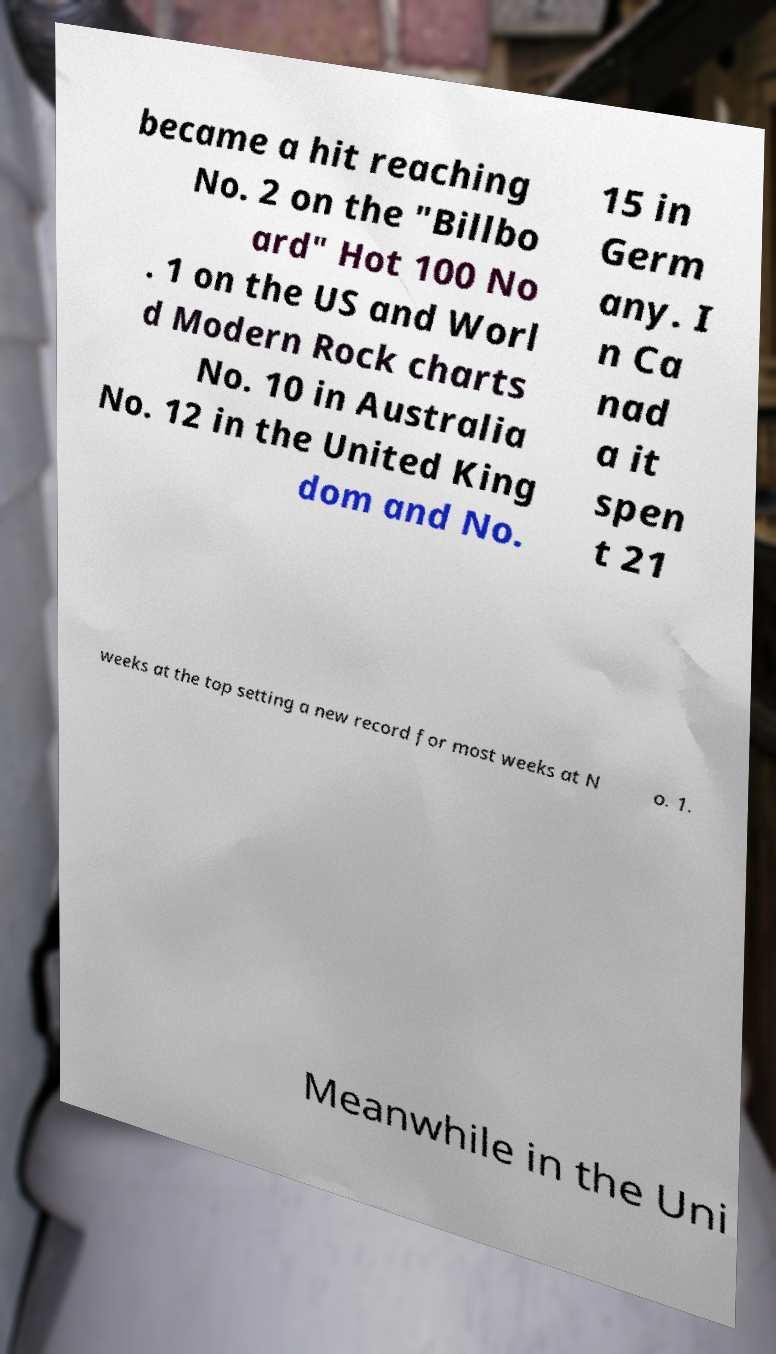Could you assist in decoding the text presented in this image and type it out clearly? became a hit reaching No. 2 on the "Billbo ard" Hot 100 No . 1 on the US and Worl d Modern Rock charts No. 10 in Australia No. 12 in the United King dom and No. 15 in Germ any. I n Ca nad a it spen t 21 weeks at the top setting a new record for most weeks at N o. 1. Meanwhile in the Uni 